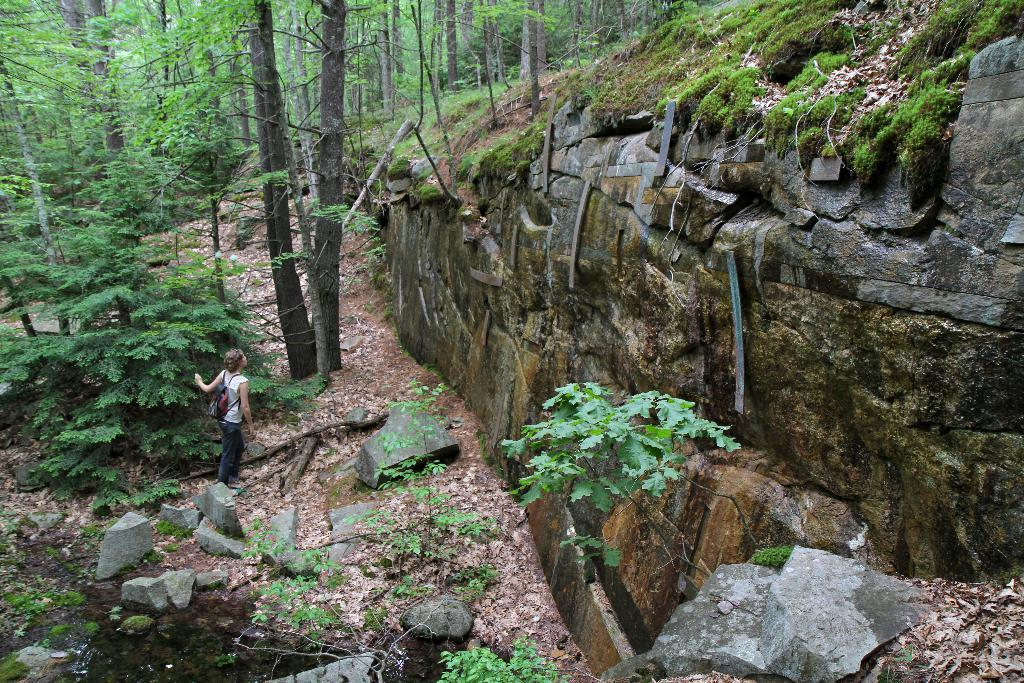What is the main subject of the image? There is a person in the image. What is the person carrying? The person is carrying a bag. What type of natural environment is depicted in the image? There are rocks, grass, leaves, and trees visible in the image. How does the ink in the image contribute to the overall composition? There is no ink present in the image, as it is a photograph of a person in a natural environment. 